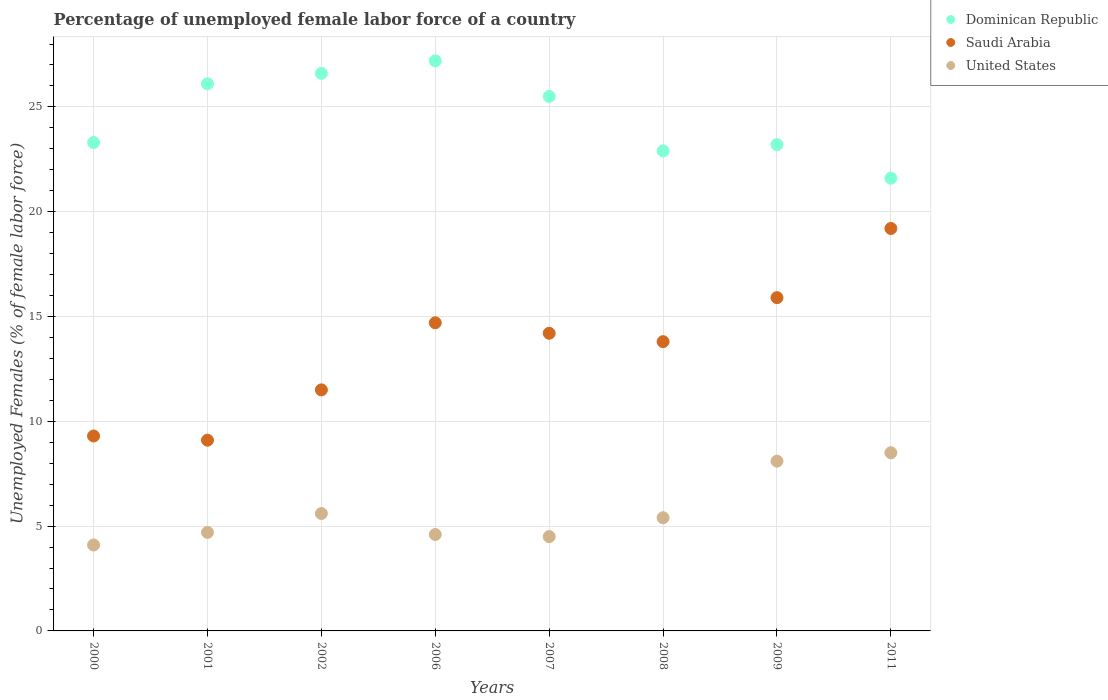How many different coloured dotlines are there?
Your answer should be very brief. 3. Is the number of dotlines equal to the number of legend labels?
Provide a short and direct response. Yes. What is the percentage of unemployed female labor force in Saudi Arabia in 2007?
Provide a succinct answer. 14.2. Across all years, what is the maximum percentage of unemployed female labor force in Dominican Republic?
Offer a very short reply. 27.2. Across all years, what is the minimum percentage of unemployed female labor force in United States?
Ensure brevity in your answer.  4.1. In which year was the percentage of unemployed female labor force in Saudi Arabia maximum?
Your answer should be compact. 2011. In which year was the percentage of unemployed female labor force in Saudi Arabia minimum?
Your answer should be very brief. 2001. What is the total percentage of unemployed female labor force in Saudi Arabia in the graph?
Ensure brevity in your answer.  107.7. What is the difference between the percentage of unemployed female labor force in Saudi Arabia in 2002 and that in 2006?
Your answer should be very brief. -3.2. What is the difference between the percentage of unemployed female labor force in United States in 2002 and the percentage of unemployed female labor force in Dominican Republic in 2009?
Your answer should be compact. -17.6. What is the average percentage of unemployed female labor force in Dominican Republic per year?
Ensure brevity in your answer.  24.55. In the year 2007, what is the difference between the percentage of unemployed female labor force in Saudi Arabia and percentage of unemployed female labor force in Dominican Republic?
Keep it short and to the point. -11.3. In how many years, is the percentage of unemployed female labor force in Dominican Republic greater than 11 %?
Make the answer very short. 8. What is the ratio of the percentage of unemployed female labor force in Dominican Republic in 2008 to that in 2011?
Give a very brief answer. 1.06. Is the difference between the percentage of unemployed female labor force in Saudi Arabia in 2008 and 2009 greater than the difference between the percentage of unemployed female labor force in Dominican Republic in 2008 and 2009?
Your answer should be compact. No. What is the difference between the highest and the second highest percentage of unemployed female labor force in Saudi Arabia?
Your response must be concise. 3.3. What is the difference between the highest and the lowest percentage of unemployed female labor force in Saudi Arabia?
Ensure brevity in your answer.  10.1. In how many years, is the percentage of unemployed female labor force in United States greater than the average percentage of unemployed female labor force in United States taken over all years?
Keep it short and to the point. 2. Is the sum of the percentage of unemployed female labor force in Dominican Republic in 2002 and 2007 greater than the maximum percentage of unemployed female labor force in Saudi Arabia across all years?
Keep it short and to the point. Yes. Is the percentage of unemployed female labor force in Saudi Arabia strictly less than the percentage of unemployed female labor force in United States over the years?
Ensure brevity in your answer.  No. How many years are there in the graph?
Offer a terse response. 8. Does the graph contain any zero values?
Give a very brief answer. No. Where does the legend appear in the graph?
Give a very brief answer. Top right. What is the title of the graph?
Make the answer very short. Percentage of unemployed female labor force of a country. Does "Burundi" appear as one of the legend labels in the graph?
Provide a short and direct response. No. What is the label or title of the X-axis?
Provide a succinct answer. Years. What is the label or title of the Y-axis?
Provide a short and direct response. Unemployed Females (% of female labor force). What is the Unemployed Females (% of female labor force) of Dominican Republic in 2000?
Your answer should be very brief. 23.3. What is the Unemployed Females (% of female labor force) in Saudi Arabia in 2000?
Provide a short and direct response. 9.3. What is the Unemployed Females (% of female labor force) of United States in 2000?
Offer a terse response. 4.1. What is the Unemployed Females (% of female labor force) of Dominican Republic in 2001?
Keep it short and to the point. 26.1. What is the Unemployed Females (% of female labor force) of Saudi Arabia in 2001?
Provide a succinct answer. 9.1. What is the Unemployed Females (% of female labor force) in United States in 2001?
Your answer should be very brief. 4.7. What is the Unemployed Females (% of female labor force) in Dominican Republic in 2002?
Provide a short and direct response. 26.6. What is the Unemployed Females (% of female labor force) in Saudi Arabia in 2002?
Offer a terse response. 11.5. What is the Unemployed Females (% of female labor force) of United States in 2002?
Your answer should be compact. 5.6. What is the Unemployed Females (% of female labor force) in Dominican Republic in 2006?
Provide a succinct answer. 27.2. What is the Unemployed Females (% of female labor force) of Saudi Arabia in 2006?
Provide a succinct answer. 14.7. What is the Unemployed Females (% of female labor force) in United States in 2006?
Provide a short and direct response. 4.6. What is the Unemployed Females (% of female labor force) of Dominican Republic in 2007?
Offer a very short reply. 25.5. What is the Unemployed Females (% of female labor force) of Saudi Arabia in 2007?
Your answer should be very brief. 14.2. What is the Unemployed Females (% of female labor force) of Dominican Republic in 2008?
Keep it short and to the point. 22.9. What is the Unemployed Females (% of female labor force) of Saudi Arabia in 2008?
Ensure brevity in your answer.  13.8. What is the Unemployed Females (% of female labor force) in United States in 2008?
Give a very brief answer. 5.4. What is the Unemployed Females (% of female labor force) of Dominican Republic in 2009?
Make the answer very short. 23.2. What is the Unemployed Females (% of female labor force) in Saudi Arabia in 2009?
Your answer should be compact. 15.9. What is the Unemployed Females (% of female labor force) in United States in 2009?
Your answer should be compact. 8.1. What is the Unemployed Females (% of female labor force) in Dominican Republic in 2011?
Provide a short and direct response. 21.6. What is the Unemployed Females (% of female labor force) in Saudi Arabia in 2011?
Make the answer very short. 19.2. Across all years, what is the maximum Unemployed Females (% of female labor force) in Dominican Republic?
Give a very brief answer. 27.2. Across all years, what is the maximum Unemployed Females (% of female labor force) of Saudi Arabia?
Offer a terse response. 19.2. Across all years, what is the minimum Unemployed Females (% of female labor force) of Dominican Republic?
Provide a succinct answer. 21.6. Across all years, what is the minimum Unemployed Females (% of female labor force) of Saudi Arabia?
Provide a short and direct response. 9.1. Across all years, what is the minimum Unemployed Females (% of female labor force) in United States?
Provide a short and direct response. 4.1. What is the total Unemployed Females (% of female labor force) in Dominican Republic in the graph?
Ensure brevity in your answer.  196.4. What is the total Unemployed Females (% of female labor force) in Saudi Arabia in the graph?
Offer a terse response. 107.7. What is the total Unemployed Females (% of female labor force) of United States in the graph?
Ensure brevity in your answer.  45.5. What is the difference between the Unemployed Females (% of female labor force) in Saudi Arabia in 2000 and that in 2002?
Ensure brevity in your answer.  -2.2. What is the difference between the Unemployed Females (% of female labor force) in United States in 2000 and that in 2002?
Provide a succinct answer. -1.5. What is the difference between the Unemployed Females (% of female labor force) of Saudi Arabia in 2000 and that in 2006?
Offer a very short reply. -5.4. What is the difference between the Unemployed Females (% of female labor force) in United States in 2000 and that in 2006?
Give a very brief answer. -0.5. What is the difference between the Unemployed Females (% of female labor force) in Dominican Republic in 2000 and that in 2007?
Provide a short and direct response. -2.2. What is the difference between the Unemployed Females (% of female labor force) of Saudi Arabia in 2000 and that in 2007?
Your answer should be compact. -4.9. What is the difference between the Unemployed Females (% of female labor force) in Dominican Republic in 2000 and that in 2008?
Provide a succinct answer. 0.4. What is the difference between the Unemployed Females (% of female labor force) in United States in 2000 and that in 2009?
Make the answer very short. -4. What is the difference between the Unemployed Females (% of female labor force) in Dominican Republic in 2000 and that in 2011?
Your answer should be very brief. 1.7. What is the difference between the Unemployed Females (% of female labor force) in Saudi Arabia in 2000 and that in 2011?
Provide a succinct answer. -9.9. What is the difference between the Unemployed Females (% of female labor force) of United States in 2001 and that in 2002?
Provide a succinct answer. -0.9. What is the difference between the Unemployed Females (% of female labor force) of Dominican Republic in 2001 and that in 2006?
Give a very brief answer. -1.1. What is the difference between the Unemployed Females (% of female labor force) of Saudi Arabia in 2001 and that in 2006?
Your answer should be compact. -5.6. What is the difference between the Unemployed Females (% of female labor force) of United States in 2001 and that in 2006?
Your answer should be very brief. 0.1. What is the difference between the Unemployed Females (% of female labor force) in Saudi Arabia in 2001 and that in 2007?
Keep it short and to the point. -5.1. What is the difference between the Unemployed Females (% of female labor force) of Saudi Arabia in 2001 and that in 2009?
Provide a short and direct response. -6.8. What is the difference between the Unemployed Females (% of female labor force) of Saudi Arabia in 2001 and that in 2011?
Offer a terse response. -10.1. What is the difference between the Unemployed Females (% of female labor force) in United States in 2001 and that in 2011?
Your answer should be compact. -3.8. What is the difference between the Unemployed Females (% of female labor force) in Saudi Arabia in 2002 and that in 2006?
Provide a short and direct response. -3.2. What is the difference between the Unemployed Females (% of female labor force) of Dominican Republic in 2002 and that in 2007?
Provide a succinct answer. 1.1. What is the difference between the Unemployed Females (% of female labor force) in United States in 2002 and that in 2007?
Keep it short and to the point. 1.1. What is the difference between the Unemployed Females (% of female labor force) of Saudi Arabia in 2002 and that in 2008?
Your response must be concise. -2.3. What is the difference between the Unemployed Females (% of female labor force) of Saudi Arabia in 2002 and that in 2009?
Give a very brief answer. -4.4. What is the difference between the Unemployed Females (% of female labor force) of Dominican Republic in 2002 and that in 2011?
Provide a short and direct response. 5. What is the difference between the Unemployed Females (% of female labor force) in Saudi Arabia in 2002 and that in 2011?
Offer a terse response. -7.7. What is the difference between the Unemployed Females (% of female labor force) of United States in 2002 and that in 2011?
Offer a terse response. -2.9. What is the difference between the Unemployed Females (% of female labor force) of Saudi Arabia in 2006 and that in 2007?
Your response must be concise. 0.5. What is the difference between the Unemployed Females (% of female labor force) in United States in 2006 and that in 2007?
Ensure brevity in your answer.  0.1. What is the difference between the Unemployed Females (% of female labor force) of Dominican Republic in 2006 and that in 2008?
Provide a short and direct response. 4.3. What is the difference between the Unemployed Females (% of female labor force) in Saudi Arabia in 2006 and that in 2008?
Your answer should be very brief. 0.9. What is the difference between the Unemployed Females (% of female labor force) of Saudi Arabia in 2007 and that in 2008?
Provide a succinct answer. 0.4. What is the difference between the Unemployed Females (% of female labor force) of Saudi Arabia in 2007 and that in 2009?
Ensure brevity in your answer.  -1.7. What is the difference between the Unemployed Females (% of female labor force) in United States in 2007 and that in 2009?
Offer a very short reply. -3.6. What is the difference between the Unemployed Females (% of female labor force) of Saudi Arabia in 2007 and that in 2011?
Offer a very short reply. -5. What is the difference between the Unemployed Females (% of female labor force) in United States in 2007 and that in 2011?
Your answer should be very brief. -4. What is the difference between the Unemployed Females (% of female labor force) of Dominican Republic in 2008 and that in 2009?
Ensure brevity in your answer.  -0.3. What is the difference between the Unemployed Females (% of female labor force) in Dominican Republic in 2008 and that in 2011?
Provide a short and direct response. 1.3. What is the difference between the Unemployed Females (% of female labor force) of Saudi Arabia in 2008 and that in 2011?
Give a very brief answer. -5.4. What is the difference between the Unemployed Females (% of female labor force) of United States in 2008 and that in 2011?
Make the answer very short. -3.1. What is the difference between the Unemployed Females (% of female labor force) of Saudi Arabia in 2009 and that in 2011?
Ensure brevity in your answer.  -3.3. What is the difference between the Unemployed Females (% of female labor force) of Dominican Republic in 2000 and the Unemployed Females (% of female labor force) of Saudi Arabia in 2001?
Provide a succinct answer. 14.2. What is the difference between the Unemployed Females (% of female labor force) of Dominican Republic in 2000 and the Unemployed Females (% of female labor force) of United States in 2006?
Your response must be concise. 18.7. What is the difference between the Unemployed Females (% of female labor force) of Dominican Republic in 2000 and the Unemployed Females (% of female labor force) of United States in 2007?
Offer a very short reply. 18.8. What is the difference between the Unemployed Females (% of female labor force) of Saudi Arabia in 2000 and the Unemployed Females (% of female labor force) of United States in 2007?
Provide a short and direct response. 4.8. What is the difference between the Unemployed Females (% of female labor force) of Dominican Republic in 2000 and the Unemployed Females (% of female labor force) of Saudi Arabia in 2008?
Your answer should be compact. 9.5. What is the difference between the Unemployed Females (% of female labor force) in Dominican Republic in 2000 and the Unemployed Females (% of female labor force) in Saudi Arabia in 2009?
Your answer should be very brief. 7.4. What is the difference between the Unemployed Females (% of female labor force) in Dominican Republic in 2000 and the Unemployed Females (% of female labor force) in Saudi Arabia in 2011?
Ensure brevity in your answer.  4.1. What is the difference between the Unemployed Females (% of female labor force) of Dominican Republic in 2000 and the Unemployed Females (% of female labor force) of United States in 2011?
Keep it short and to the point. 14.8. What is the difference between the Unemployed Females (% of female labor force) of Saudi Arabia in 2001 and the Unemployed Females (% of female labor force) of United States in 2002?
Give a very brief answer. 3.5. What is the difference between the Unemployed Females (% of female labor force) of Dominican Republic in 2001 and the Unemployed Females (% of female labor force) of Saudi Arabia in 2006?
Offer a terse response. 11.4. What is the difference between the Unemployed Females (% of female labor force) of Dominican Republic in 2001 and the Unemployed Females (% of female labor force) of United States in 2006?
Your answer should be compact. 21.5. What is the difference between the Unemployed Females (% of female labor force) in Dominican Republic in 2001 and the Unemployed Females (% of female labor force) in Saudi Arabia in 2007?
Offer a very short reply. 11.9. What is the difference between the Unemployed Females (% of female labor force) in Dominican Republic in 2001 and the Unemployed Females (% of female labor force) in United States in 2007?
Offer a terse response. 21.6. What is the difference between the Unemployed Females (% of female labor force) of Dominican Republic in 2001 and the Unemployed Females (% of female labor force) of United States in 2008?
Your response must be concise. 20.7. What is the difference between the Unemployed Females (% of female labor force) in Saudi Arabia in 2001 and the Unemployed Females (% of female labor force) in United States in 2008?
Make the answer very short. 3.7. What is the difference between the Unemployed Females (% of female labor force) in Dominican Republic in 2001 and the Unemployed Females (% of female labor force) in United States in 2009?
Offer a terse response. 18. What is the difference between the Unemployed Females (% of female labor force) of Saudi Arabia in 2001 and the Unemployed Females (% of female labor force) of United States in 2009?
Provide a succinct answer. 1. What is the difference between the Unemployed Females (% of female labor force) of Saudi Arabia in 2001 and the Unemployed Females (% of female labor force) of United States in 2011?
Ensure brevity in your answer.  0.6. What is the difference between the Unemployed Females (% of female labor force) of Dominican Republic in 2002 and the Unemployed Females (% of female labor force) of Saudi Arabia in 2006?
Offer a terse response. 11.9. What is the difference between the Unemployed Females (% of female labor force) in Dominican Republic in 2002 and the Unemployed Females (% of female labor force) in United States in 2007?
Your answer should be compact. 22.1. What is the difference between the Unemployed Females (% of female labor force) in Saudi Arabia in 2002 and the Unemployed Females (% of female labor force) in United States in 2007?
Provide a succinct answer. 7. What is the difference between the Unemployed Females (% of female labor force) of Dominican Republic in 2002 and the Unemployed Females (% of female labor force) of United States in 2008?
Your answer should be very brief. 21.2. What is the difference between the Unemployed Females (% of female labor force) in Saudi Arabia in 2002 and the Unemployed Females (% of female labor force) in United States in 2008?
Keep it short and to the point. 6.1. What is the difference between the Unemployed Females (% of female labor force) in Dominican Republic in 2002 and the Unemployed Females (% of female labor force) in United States in 2009?
Keep it short and to the point. 18.5. What is the difference between the Unemployed Females (% of female labor force) in Dominican Republic in 2006 and the Unemployed Females (% of female labor force) in Saudi Arabia in 2007?
Give a very brief answer. 13. What is the difference between the Unemployed Females (% of female labor force) of Dominican Republic in 2006 and the Unemployed Females (% of female labor force) of United States in 2007?
Your answer should be very brief. 22.7. What is the difference between the Unemployed Females (% of female labor force) in Dominican Republic in 2006 and the Unemployed Females (% of female labor force) in United States in 2008?
Ensure brevity in your answer.  21.8. What is the difference between the Unemployed Females (% of female labor force) of Saudi Arabia in 2006 and the Unemployed Females (% of female labor force) of United States in 2009?
Keep it short and to the point. 6.6. What is the difference between the Unemployed Females (% of female labor force) in Dominican Republic in 2006 and the Unemployed Females (% of female labor force) in United States in 2011?
Ensure brevity in your answer.  18.7. What is the difference between the Unemployed Females (% of female labor force) of Saudi Arabia in 2006 and the Unemployed Females (% of female labor force) of United States in 2011?
Offer a terse response. 6.2. What is the difference between the Unemployed Females (% of female labor force) of Dominican Republic in 2007 and the Unemployed Females (% of female labor force) of Saudi Arabia in 2008?
Make the answer very short. 11.7. What is the difference between the Unemployed Females (% of female labor force) in Dominican Republic in 2007 and the Unemployed Females (% of female labor force) in United States in 2008?
Provide a succinct answer. 20.1. What is the difference between the Unemployed Females (% of female labor force) of Saudi Arabia in 2007 and the Unemployed Females (% of female labor force) of United States in 2008?
Ensure brevity in your answer.  8.8. What is the difference between the Unemployed Females (% of female labor force) of Dominican Republic in 2007 and the Unemployed Females (% of female labor force) of Saudi Arabia in 2009?
Keep it short and to the point. 9.6. What is the difference between the Unemployed Females (% of female labor force) in Dominican Republic in 2007 and the Unemployed Females (% of female labor force) in United States in 2009?
Make the answer very short. 17.4. What is the difference between the Unemployed Females (% of female labor force) in Dominican Republic in 2007 and the Unemployed Females (% of female labor force) in Saudi Arabia in 2011?
Offer a terse response. 6.3. What is the difference between the Unemployed Females (% of female labor force) of Dominican Republic in 2007 and the Unemployed Females (% of female labor force) of United States in 2011?
Your response must be concise. 17. What is the difference between the Unemployed Females (% of female labor force) of Dominican Republic in 2008 and the Unemployed Females (% of female labor force) of Saudi Arabia in 2011?
Ensure brevity in your answer.  3.7. What is the difference between the Unemployed Females (% of female labor force) in Dominican Republic in 2008 and the Unemployed Females (% of female labor force) in United States in 2011?
Keep it short and to the point. 14.4. What is the difference between the Unemployed Females (% of female labor force) of Saudi Arabia in 2008 and the Unemployed Females (% of female labor force) of United States in 2011?
Provide a short and direct response. 5.3. What is the difference between the Unemployed Females (% of female labor force) of Dominican Republic in 2009 and the Unemployed Females (% of female labor force) of Saudi Arabia in 2011?
Give a very brief answer. 4. What is the difference between the Unemployed Females (% of female labor force) in Dominican Republic in 2009 and the Unemployed Females (% of female labor force) in United States in 2011?
Keep it short and to the point. 14.7. What is the average Unemployed Females (% of female labor force) of Dominican Republic per year?
Offer a terse response. 24.55. What is the average Unemployed Females (% of female labor force) in Saudi Arabia per year?
Give a very brief answer. 13.46. What is the average Unemployed Females (% of female labor force) in United States per year?
Your answer should be compact. 5.69. In the year 2000, what is the difference between the Unemployed Females (% of female labor force) of Dominican Republic and Unemployed Females (% of female labor force) of Saudi Arabia?
Give a very brief answer. 14. In the year 2000, what is the difference between the Unemployed Females (% of female labor force) of Saudi Arabia and Unemployed Females (% of female labor force) of United States?
Offer a very short reply. 5.2. In the year 2001, what is the difference between the Unemployed Females (% of female labor force) in Dominican Republic and Unemployed Females (% of female labor force) in United States?
Provide a short and direct response. 21.4. In the year 2002, what is the difference between the Unemployed Females (% of female labor force) of Dominican Republic and Unemployed Females (% of female labor force) of Saudi Arabia?
Your response must be concise. 15.1. In the year 2002, what is the difference between the Unemployed Females (% of female labor force) of Saudi Arabia and Unemployed Females (% of female labor force) of United States?
Your answer should be very brief. 5.9. In the year 2006, what is the difference between the Unemployed Females (% of female labor force) of Dominican Republic and Unemployed Females (% of female labor force) of United States?
Keep it short and to the point. 22.6. In the year 2006, what is the difference between the Unemployed Females (% of female labor force) in Saudi Arabia and Unemployed Females (% of female labor force) in United States?
Provide a short and direct response. 10.1. In the year 2007, what is the difference between the Unemployed Females (% of female labor force) of Dominican Republic and Unemployed Females (% of female labor force) of Saudi Arabia?
Your answer should be compact. 11.3. In the year 2007, what is the difference between the Unemployed Females (% of female labor force) in Saudi Arabia and Unemployed Females (% of female labor force) in United States?
Provide a succinct answer. 9.7. In the year 2008, what is the difference between the Unemployed Females (% of female labor force) in Dominican Republic and Unemployed Females (% of female labor force) in United States?
Offer a very short reply. 17.5. In the year 2008, what is the difference between the Unemployed Females (% of female labor force) of Saudi Arabia and Unemployed Females (% of female labor force) of United States?
Give a very brief answer. 8.4. In the year 2009, what is the difference between the Unemployed Females (% of female labor force) in Dominican Republic and Unemployed Females (% of female labor force) in United States?
Give a very brief answer. 15.1. In the year 2009, what is the difference between the Unemployed Females (% of female labor force) of Saudi Arabia and Unemployed Females (% of female labor force) of United States?
Make the answer very short. 7.8. In the year 2011, what is the difference between the Unemployed Females (% of female labor force) in Dominican Republic and Unemployed Females (% of female labor force) in United States?
Give a very brief answer. 13.1. In the year 2011, what is the difference between the Unemployed Females (% of female labor force) in Saudi Arabia and Unemployed Females (% of female labor force) in United States?
Provide a succinct answer. 10.7. What is the ratio of the Unemployed Females (% of female labor force) of Dominican Republic in 2000 to that in 2001?
Provide a short and direct response. 0.89. What is the ratio of the Unemployed Females (% of female labor force) in United States in 2000 to that in 2001?
Ensure brevity in your answer.  0.87. What is the ratio of the Unemployed Females (% of female labor force) in Dominican Republic in 2000 to that in 2002?
Provide a short and direct response. 0.88. What is the ratio of the Unemployed Females (% of female labor force) of Saudi Arabia in 2000 to that in 2002?
Provide a short and direct response. 0.81. What is the ratio of the Unemployed Females (% of female labor force) of United States in 2000 to that in 2002?
Keep it short and to the point. 0.73. What is the ratio of the Unemployed Females (% of female labor force) in Dominican Republic in 2000 to that in 2006?
Provide a short and direct response. 0.86. What is the ratio of the Unemployed Females (% of female labor force) of Saudi Arabia in 2000 to that in 2006?
Your answer should be very brief. 0.63. What is the ratio of the Unemployed Females (% of female labor force) of United States in 2000 to that in 2006?
Make the answer very short. 0.89. What is the ratio of the Unemployed Females (% of female labor force) in Dominican Republic in 2000 to that in 2007?
Offer a very short reply. 0.91. What is the ratio of the Unemployed Females (% of female labor force) in Saudi Arabia in 2000 to that in 2007?
Make the answer very short. 0.65. What is the ratio of the Unemployed Females (% of female labor force) in United States in 2000 to that in 2007?
Give a very brief answer. 0.91. What is the ratio of the Unemployed Females (% of female labor force) in Dominican Republic in 2000 to that in 2008?
Your response must be concise. 1.02. What is the ratio of the Unemployed Females (% of female labor force) of Saudi Arabia in 2000 to that in 2008?
Provide a short and direct response. 0.67. What is the ratio of the Unemployed Females (% of female labor force) in United States in 2000 to that in 2008?
Your answer should be compact. 0.76. What is the ratio of the Unemployed Females (% of female labor force) in Saudi Arabia in 2000 to that in 2009?
Your answer should be very brief. 0.58. What is the ratio of the Unemployed Females (% of female labor force) in United States in 2000 to that in 2009?
Keep it short and to the point. 0.51. What is the ratio of the Unemployed Females (% of female labor force) in Dominican Republic in 2000 to that in 2011?
Provide a succinct answer. 1.08. What is the ratio of the Unemployed Females (% of female labor force) in Saudi Arabia in 2000 to that in 2011?
Provide a succinct answer. 0.48. What is the ratio of the Unemployed Females (% of female labor force) in United States in 2000 to that in 2011?
Provide a succinct answer. 0.48. What is the ratio of the Unemployed Females (% of female labor force) in Dominican Republic in 2001 to that in 2002?
Provide a succinct answer. 0.98. What is the ratio of the Unemployed Females (% of female labor force) of Saudi Arabia in 2001 to that in 2002?
Offer a terse response. 0.79. What is the ratio of the Unemployed Females (% of female labor force) in United States in 2001 to that in 2002?
Provide a short and direct response. 0.84. What is the ratio of the Unemployed Females (% of female labor force) of Dominican Republic in 2001 to that in 2006?
Your answer should be very brief. 0.96. What is the ratio of the Unemployed Females (% of female labor force) of Saudi Arabia in 2001 to that in 2006?
Your answer should be compact. 0.62. What is the ratio of the Unemployed Females (% of female labor force) of United States in 2001 to that in 2006?
Provide a succinct answer. 1.02. What is the ratio of the Unemployed Females (% of female labor force) in Dominican Republic in 2001 to that in 2007?
Your answer should be very brief. 1.02. What is the ratio of the Unemployed Females (% of female labor force) of Saudi Arabia in 2001 to that in 2007?
Your answer should be compact. 0.64. What is the ratio of the Unemployed Females (% of female labor force) of United States in 2001 to that in 2007?
Your answer should be very brief. 1.04. What is the ratio of the Unemployed Females (% of female labor force) of Dominican Republic in 2001 to that in 2008?
Your answer should be very brief. 1.14. What is the ratio of the Unemployed Females (% of female labor force) of Saudi Arabia in 2001 to that in 2008?
Your answer should be very brief. 0.66. What is the ratio of the Unemployed Females (% of female labor force) of United States in 2001 to that in 2008?
Give a very brief answer. 0.87. What is the ratio of the Unemployed Females (% of female labor force) of Saudi Arabia in 2001 to that in 2009?
Give a very brief answer. 0.57. What is the ratio of the Unemployed Females (% of female labor force) of United States in 2001 to that in 2009?
Keep it short and to the point. 0.58. What is the ratio of the Unemployed Females (% of female labor force) in Dominican Republic in 2001 to that in 2011?
Your answer should be compact. 1.21. What is the ratio of the Unemployed Females (% of female labor force) in Saudi Arabia in 2001 to that in 2011?
Your response must be concise. 0.47. What is the ratio of the Unemployed Females (% of female labor force) of United States in 2001 to that in 2011?
Provide a short and direct response. 0.55. What is the ratio of the Unemployed Females (% of female labor force) of Dominican Republic in 2002 to that in 2006?
Your answer should be compact. 0.98. What is the ratio of the Unemployed Females (% of female labor force) of Saudi Arabia in 2002 to that in 2006?
Make the answer very short. 0.78. What is the ratio of the Unemployed Females (% of female labor force) in United States in 2002 to that in 2006?
Offer a very short reply. 1.22. What is the ratio of the Unemployed Females (% of female labor force) of Dominican Republic in 2002 to that in 2007?
Provide a short and direct response. 1.04. What is the ratio of the Unemployed Females (% of female labor force) of Saudi Arabia in 2002 to that in 2007?
Your answer should be compact. 0.81. What is the ratio of the Unemployed Females (% of female labor force) in United States in 2002 to that in 2007?
Give a very brief answer. 1.24. What is the ratio of the Unemployed Females (% of female labor force) of Dominican Republic in 2002 to that in 2008?
Offer a terse response. 1.16. What is the ratio of the Unemployed Females (% of female labor force) of Saudi Arabia in 2002 to that in 2008?
Give a very brief answer. 0.83. What is the ratio of the Unemployed Females (% of female labor force) of United States in 2002 to that in 2008?
Ensure brevity in your answer.  1.04. What is the ratio of the Unemployed Females (% of female labor force) of Dominican Republic in 2002 to that in 2009?
Give a very brief answer. 1.15. What is the ratio of the Unemployed Females (% of female labor force) of Saudi Arabia in 2002 to that in 2009?
Provide a short and direct response. 0.72. What is the ratio of the Unemployed Females (% of female labor force) in United States in 2002 to that in 2009?
Offer a terse response. 0.69. What is the ratio of the Unemployed Females (% of female labor force) in Dominican Republic in 2002 to that in 2011?
Provide a succinct answer. 1.23. What is the ratio of the Unemployed Females (% of female labor force) of Saudi Arabia in 2002 to that in 2011?
Provide a succinct answer. 0.6. What is the ratio of the Unemployed Females (% of female labor force) of United States in 2002 to that in 2011?
Keep it short and to the point. 0.66. What is the ratio of the Unemployed Females (% of female labor force) in Dominican Republic in 2006 to that in 2007?
Your response must be concise. 1.07. What is the ratio of the Unemployed Females (% of female labor force) in Saudi Arabia in 2006 to that in 2007?
Your answer should be very brief. 1.04. What is the ratio of the Unemployed Females (% of female labor force) of United States in 2006 to that in 2007?
Your response must be concise. 1.02. What is the ratio of the Unemployed Females (% of female labor force) of Dominican Republic in 2006 to that in 2008?
Your response must be concise. 1.19. What is the ratio of the Unemployed Females (% of female labor force) of Saudi Arabia in 2006 to that in 2008?
Provide a succinct answer. 1.07. What is the ratio of the Unemployed Females (% of female labor force) of United States in 2006 to that in 2008?
Give a very brief answer. 0.85. What is the ratio of the Unemployed Females (% of female labor force) of Dominican Republic in 2006 to that in 2009?
Offer a very short reply. 1.17. What is the ratio of the Unemployed Females (% of female labor force) in Saudi Arabia in 2006 to that in 2009?
Your answer should be very brief. 0.92. What is the ratio of the Unemployed Females (% of female labor force) in United States in 2006 to that in 2009?
Keep it short and to the point. 0.57. What is the ratio of the Unemployed Females (% of female labor force) in Dominican Republic in 2006 to that in 2011?
Make the answer very short. 1.26. What is the ratio of the Unemployed Females (% of female labor force) of Saudi Arabia in 2006 to that in 2011?
Your response must be concise. 0.77. What is the ratio of the Unemployed Females (% of female labor force) of United States in 2006 to that in 2011?
Offer a very short reply. 0.54. What is the ratio of the Unemployed Females (% of female labor force) of Dominican Republic in 2007 to that in 2008?
Make the answer very short. 1.11. What is the ratio of the Unemployed Females (% of female labor force) of Saudi Arabia in 2007 to that in 2008?
Ensure brevity in your answer.  1.03. What is the ratio of the Unemployed Females (% of female labor force) in United States in 2007 to that in 2008?
Provide a succinct answer. 0.83. What is the ratio of the Unemployed Females (% of female labor force) of Dominican Republic in 2007 to that in 2009?
Your answer should be compact. 1.1. What is the ratio of the Unemployed Females (% of female labor force) in Saudi Arabia in 2007 to that in 2009?
Provide a succinct answer. 0.89. What is the ratio of the Unemployed Females (% of female labor force) in United States in 2007 to that in 2009?
Offer a very short reply. 0.56. What is the ratio of the Unemployed Females (% of female labor force) in Dominican Republic in 2007 to that in 2011?
Offer a very short reply. 1.18. What is the ratio of the Unemployed Females (% of female labor force) of Saudi Arabia in 2007 to that in 2011?
Ensure brevity in your answer.  0.74. What is the ratio of the Unemployed Females (% of female labor force) of United States in 2007 to that in 2011?
Offer a very short reply. 0.53. What is the ratio of the Unemployed Females (% of female labor force) of Dominican Republic in 2008 to that in 2009?
Your answer should be compact. 0.99. What is the ratio of the Unemployed Females (% of female labor force) in Saudi Arabia in 2008 to that in 2009?
Offer a terse response. 0.87. What is the ratio of the Unemployed Females (% of female labor force) of Dominican Republic in 2008 to that in 2011?
Give a very brief answer. 1.06. What is the ratio of the Unemployed Females (% of female labor force) in Saudi Arabia in 2008 to that in 2011?
Provide a succinct answer. 0.72. What is the ratio of the Unemployed Females (% of female labor force) in United States in 2008 to that in 2011?
Provide a short and direct response. 0.64. What is the ratio of the Unemployed Females (% of female labor force) of Dominican Republic in 2009 to that in 2011?
Your answer should be very brief. 1.07. What is the ratio of the Unemployed Females (% of female labor force) of Saudi Arabia in 2009 to that in 2011?
Your answer should be compact. 0.83. What is the ratio of the Unemployed Females (% of female labor force) of United States in 2009 to that in 2011?
Ensure brevity in your answer.  0.95. What is the difference between the highest and the lowest Unemployed Females (% of female labor force) of United States?
Offer a terse response. 4.4. 